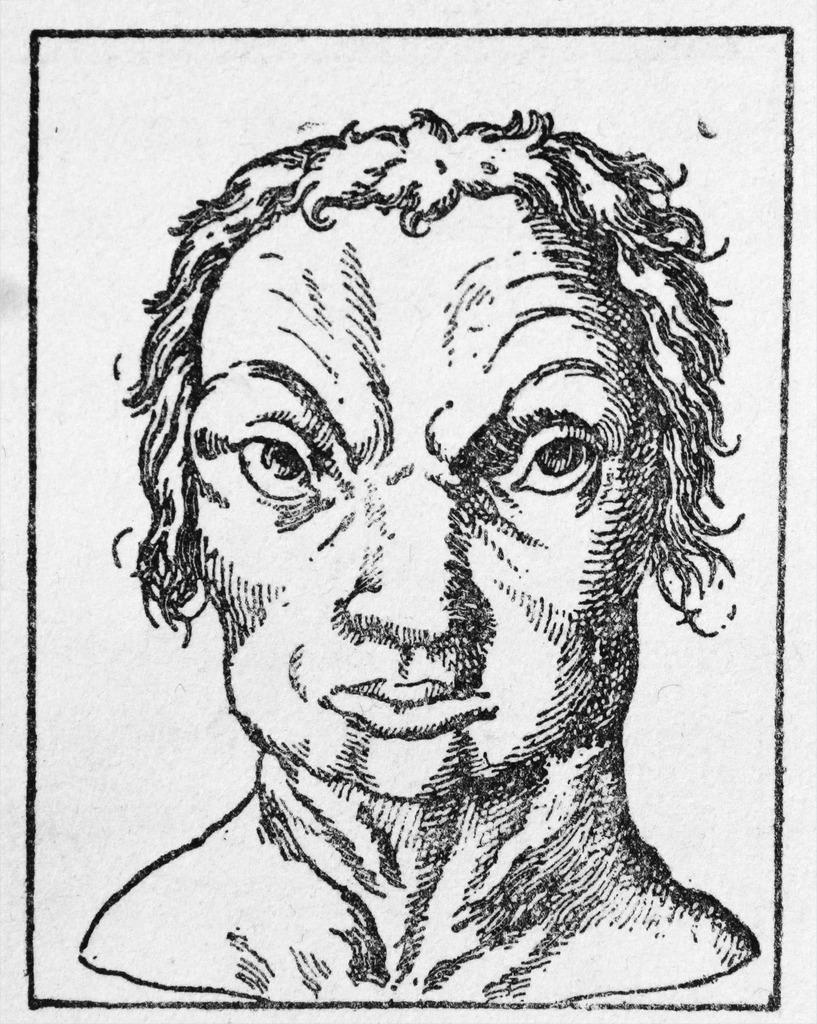What is the main subject of the image? There is a sketch of a person in the image. What color is the background of the image? The background of the image is white. How many frogs are present in the image? There are no frogs present in the image; it features a sketch of a person. What type of quilt is being used in the process depicted in the image? There is no process or quilt depicted in the image; it only contains a sketch of a person with a white background. 